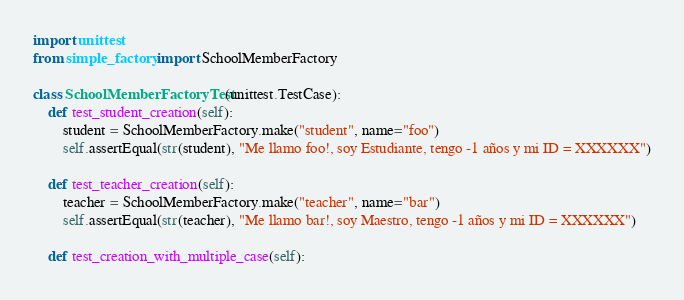Convert code to text. <code><loc_0><loc_0><loc_500><loc_500><_Python_>import unittest
from simple_factory import SchoolMemberFactory

class SchoolMemberFactoryTest(unittest.TestCase):
	def test_student_creation(self):
		student = SchoolMemberFactory.make("student", name="foo")
		self.assertEqual(str(student), "Me llamo foo!, soy Estudiante, tengo -1 años y mi ID = XXXXXX")

	def test_teacher_creation(self):
		teacher = SchoolMemberFactory.make("teacher", name="bar")
		self.assertEqual(str(teacher), "Me llamo bar!, soy Maestro, tengo -1 años y mi ID = XXXXXX")

	def test_creation_with_multiple_case(self):</code> 